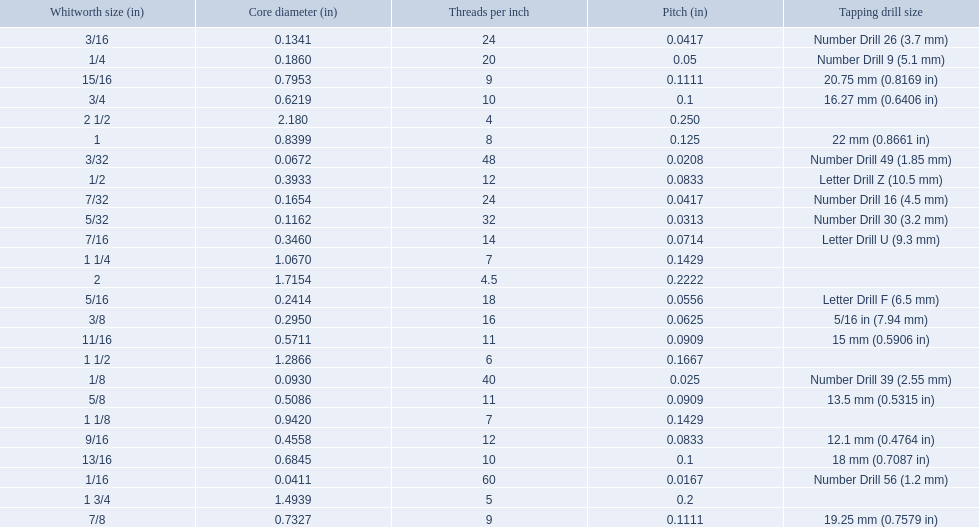What are the standard whitworth sizes in inches? 1/16, 3/32, 1/8, 5/32, 3/16, 7/32, 1/4, 5/16, 3/8, 7/16, 1/2, 9/16, 5/8, 11/16, 3/4, 13/16, 7/8, 15/16, 1, 1 1/8, 1 1/4, 1 1/2, 1 3/4, 2, 2 1/2. How many threads per inch does the 3/16 size have? 24. Which size (in inches) has the same number of threads? 7/32. 